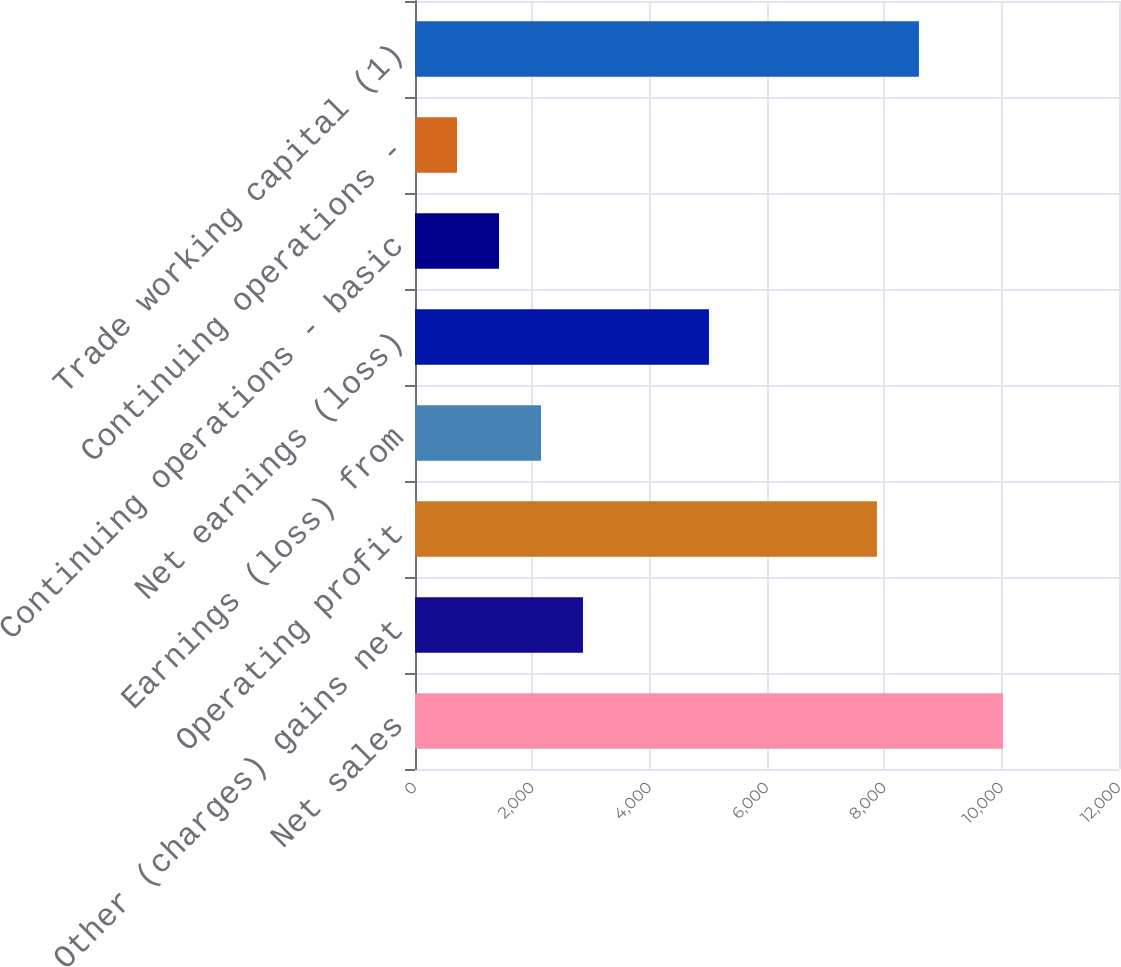<chart> <loc_0><loc_0><loc_500><loc_500><bar_chart><fcel>Net sales<fcel>Other (charges) gains net<fcel>Operating profit<fcel>Earnings (loss) from<fcel>Net earnings (loss)<fcel>Continuing operations - basic<fcel>Continuing operations -<fcel>Trade working capital (1)<nl><fcel>10021.1<fcel>2863.28<fcel>7873.74<fcel>2147.5<fcel>5010.62<fcel>1431.72<fcel>715.94<fcel>8589.52<nl></chart> 